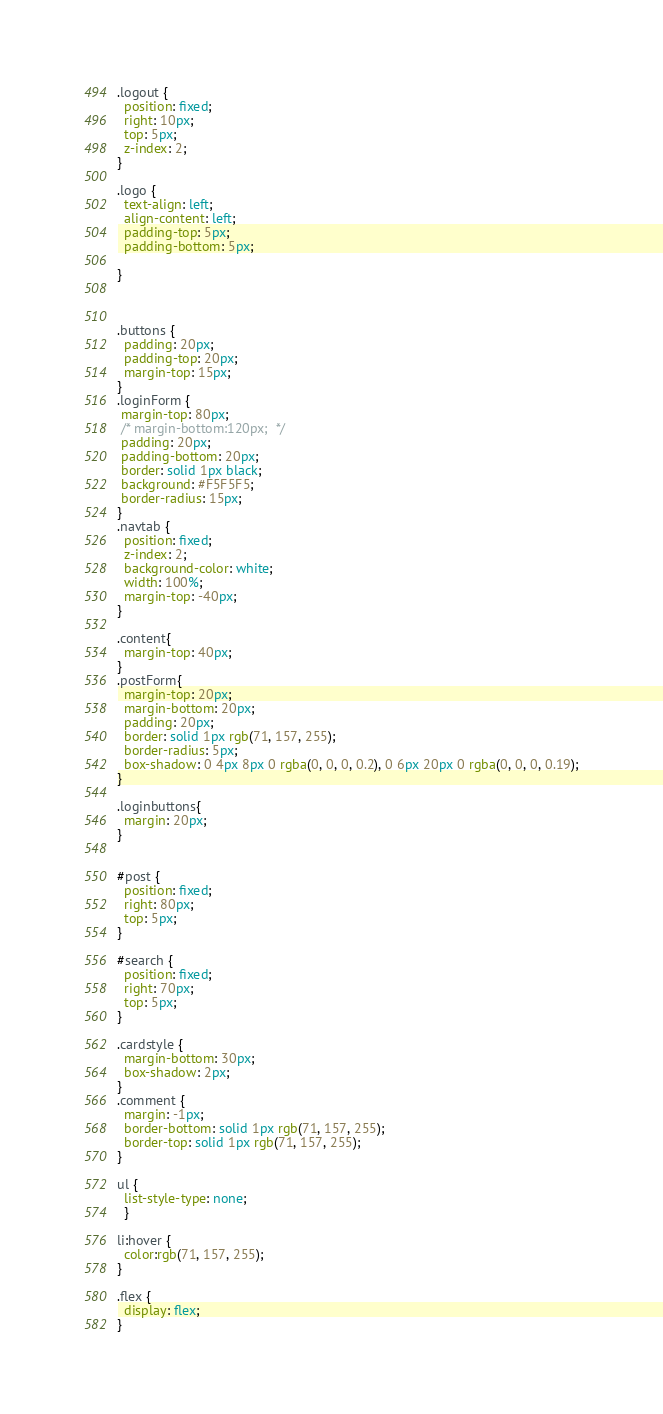<code> <loc_0><loc_0><loc_500><loc_500><_CSS_>.logout {
  position: fixed;
  right: 10px;
  top: 5px;
  z-index: 2;
}

.logo { 
  text-align: left;
  align-content: left; 
  padding-top: 5px; 
  padding-bottom: 5px; 

}



.buttons { 
  padding: 20px; 
  padding-top: 20px; 
  margin-top: 15px;
}
.loginForm {
 margin-top: 80px;
 /* margin-bottom:120px;  */
 padding: 20px;
 padding-bottom: 20px; 
 border: solid 1px black;
 background: #F5F5F5;
 border-radius: 15px;
}
.navtab {
  position: fixed;
  z-index: 2;
  background-color: white;
  width: 100%;
  margin-top: -40px;
}

.content{
  margin-top: 40px;
}
.postForm{
  margin-top: 20px;
  margin-bottom: 20px;
  padding: 20px;
  border: solid 1px rgb(71, 157, 255);
  border-radius: 5px;
  box-shadow: 0 4px 8px 0 rgba(0, 0, 0, 0.2), 0 6px 20px 0 rgba(0, 0, 0, 0.19);
}

.loginbuttons{
  margin: 20px;
}


#post {
  position: fixed;
  right: 80px;
  top: 5px;
}

#search { 
  position: fixed; 
  right: 70px; 
  top: 5px; 
}

.cardstyle {
  margin-bottom: 30px;
  box-shadow: 2px;
}
.comment {
  margin: -1px;
  border-bottom: solid 1px rgb(71, 157, 255);
  border-top: solid 1px rgb(71, 157, 255); 
}

ul {
  list-style-type: none;
  }

li:hover {
  color:rgb(71, 157, 255);
}

.flex {
  display: flex;
}




</code> 